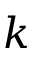Convert formula to latex. <formula><loc_0><loc_0><loc_500><loc_500>k</formula> 